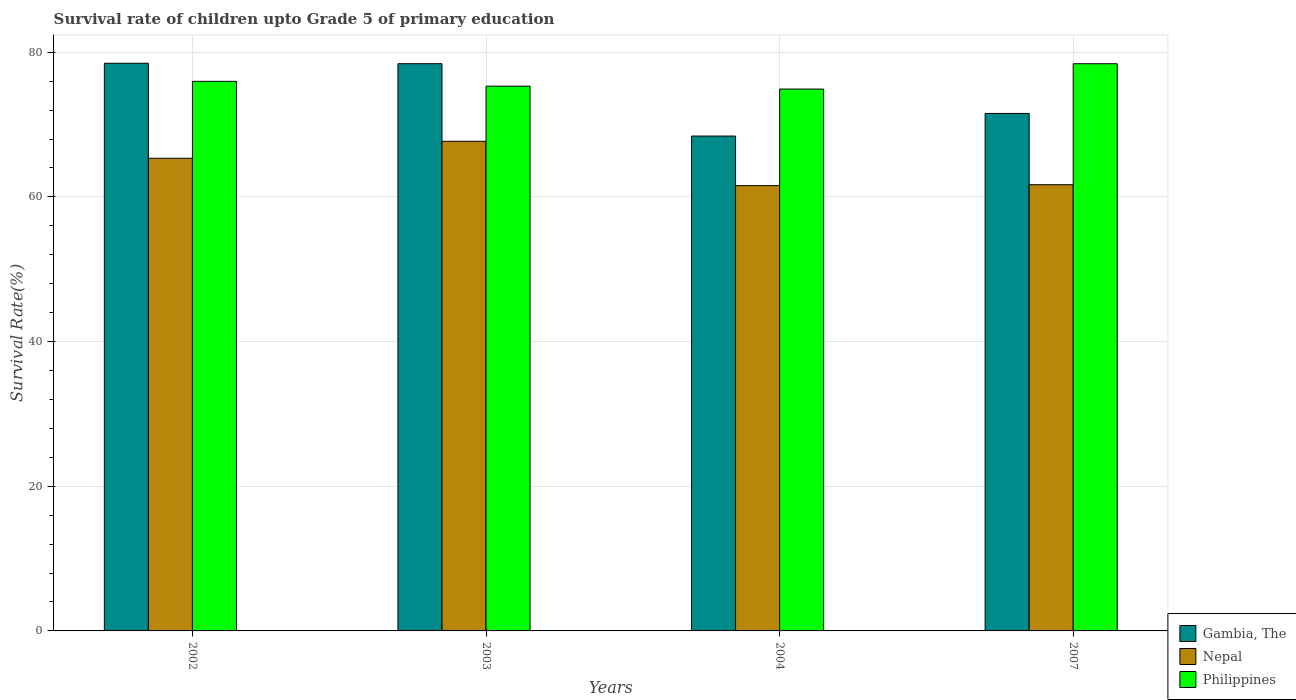How many different coloured bars are there?
Keep it short and to the point. 3. How many groups of bars are there?
Your answer should be compact. 4. Are the number of bars per tick equal to the number of legend labels?
Your answer should be compact. Yes. How many bars are there on the 1st tick from the left?
Give a very brief answer. 3. How many bars are there on the 2nd tick from the right?
Ensure brevity in your answer.  3. What is the label of the 4th group of bars from the left?
Keep it short and to the point. 2007. In how many cases, is the number of bars for a given year not equal to the number of legend labels?
Provide a short and direct response. 0. What is the survival rate of children in Gambia, The in 2004?
Offer a very short reply. 68.41. Across all years, what is the maximum survival rate of children in Philippines?
Make the answer very short. 78.41. Across all years, what is the minimum survival rate of children in Gambia, The?
Give a very brief answer. 68.41. In which year was the survival rate of children in Gambia, The maximum?
Your response must be concise. 2002. In which year was the survival rate of children in Nepal minimum?
Give a very brief answer. 2004. What is the total survival rate of children in Philippines in the graph?
Make the answer very short. 304.61. What is the difference between the survival rate of children in Philippines in 2002 and that in 2007?
Ensure brevity in your answer.  -2.43. What is the difference between the survival rate of children in Gambia, The in 2003 and the survival rate of children in Nepal in 2002?
Your answer should be very brief. 13.07. What is the average survival rate of children in Gambia, The per year?
Your response must be concise. 74.21. In the year 2004, what is the difference between the survival rate of children in Nepal and survival rate of children in Gambia, The?
Make the answer very short. -6.85. In how many years, is the survival rate of children in Gambia, The greater than 28 %?
Your answer should be compact. 4. What is the ratio of the survival rate of children in Gambia, The in 2002 to that in 2004?
Provide a succinct answer. 1.15. Is the survival rate of children in Gambia, The in 2002 less than that in 2007?
Your response must be concise. No. What is the difference between the highest and the second highest survival rate of children in Philippines?
Your answer should be compact. 2.43. What is the difference between the highest and the lowest survival rate of children in Nepal?
Your answer should be compact. 6.13. Is the sum of the survival rate of children in Gambia, The in 2002 and 2003 greater than the maximum survival rate of children in Philippines across all years?
Offer a terse response. Yes. What does the 2nd bar from the left in 2002 represents?
Provide a short and direct response. Nepal. What does the 2nd bar from the right in 2002 represents?
Provide a succinct answer. Nepal. Is it the case that in every year, the sum of the survival rate of children in Gambia, The and survival rate of children in Nepal is greater than the survival rate of children in Philippines?
Keep it short and to the point. Yes. How many bars are there?
Make the answer very short. 12. Are all the bars in the graph horizontal?
Give a very brief answer. No. Are the values on the major ticks of Y-axis written in scientific E-notation?
Your response must be concise. No. Does the graph contain grids?
Your response must be concise. Yes. Where does the legend appear in the graph?
Give a very brief answer. Bottom right. What is the title of the graph?
Offer a very short reply. Survival rate of children upto Grade 5 of primary education. What is the label or title of the X-axis?
Your response must be concise. Years. What is the label or title of the Y-axis?
Ensure brevity in your answer.  Survival Rate(%). What is the Survival Rate(%) in Gambia, The in 2002?
Make the answer very short. 78.48. What is the Survival Rate(%) of Nepal in 2002?
Your answer should be very brief. 65.34. What is the Survival Rate(%) of Philippines in 2002?
Your answer should be very brief. 75.98. What is the Survival Rate(%) in Gambia, The in 2003?
Provide a short and direct response. 78.41. What is the Survival Rate(%) in Nepal in 2003?
Provide a succinct answer. 67.69. What is the Survival Rate(%) in Philippines in 2003?
Provide a succinct answer. 75.31. What is the Survival Rate(%) of Gambia, The in 2004?
Provide a short and direct response. 68.41. What is the Survival Rate(%) of Nepal in 2004?
Offer a very short reply. 61.56. What is the Survival Rate(%) of Philippines in 2004?
Your answer should be compact. 74.91. What is the Survival Rate(%) in Gambia, The in 2007?
Keep it short and to the point. 71.54. What is the Survival Rate(%) of Nepal in 2007?
Offer a terse response. 61.69. What is the Survival Rate(%) in Philippines in 2007?
Give a very brief answer. 78.41. Across all years, what is the maximum Survival Rate(%) of Gambia, The?
Offer a very short reply. 78.48. Across all years, what is the maximum Survival Rate(%) in Nepal?
Make the answer very short. 67.69. Across all years, what is the maximum Survival Rate(%) of Philippines?
Offer a very short reply. 78.41. Across all years, what is the minimum Survival Rate(%) of Gambia, The?
Give a very brief answer. 68.41. Across all years, what is the minimum Survival Rate(%) of Nepal?
Ensure brevity in your answer.  61.56. Across all years, what is the minimum Survival Rate(%) in Philippines?
Ensure brevity in your answer.  74.91. What is the total Survival Rate(%) in Gambia, The in the graph?
Keep it short and to the point. 296.84. What is the total Survival Rate(%) of Nepal in the graph?
Give a very brief answer. 256.28. What is the total Survival Rate(%) of Philippines in the graph?
Offer a very short reply. 304.61. What is the difference between the Survival Rate(%) in Gambia, The in 2002 and that in 2003?
Give a very brief answer. 0.06. What is the difference between the Survival Rate(%) in Nepal in 2002 and that in 2003?
Make the answer very short. -2.35. What is the difference between the Survival Rate(%) of Philippines in 2002 and that in 2003?
Offer a terse response. 0.67. What is the difference between the Survival Rate(%) of Gambia, The in 2002 and that in 2004?
Provide a succinct answer. 10.06. What is the difference between the Survival Rate(%) of Nepal in 2002 and that in 2004?
Keep it short and to the point. 3.78. What is the difference between the Survival Rate(%) of Philippines in 2002 and that in 2004?
Offer a very short reply. 1.07. What is the difference between the Survival Rate(%) of Gambia, The in 2002 and that in 2007?
Offer a very short reply. 6.94. What is the difference between the Survival Rate(%) in Nepal in 2002 and that in 2007?
Your answer should be very brief. 3.66. What is the difference between the Survival Rate(%) of Philippines in 2002 and that in 2007?
Your answer should be very brief. -2.43. What is the difference between the Survival Rate(%) of Gambia, The in 2003 and that in 2004?
Give a very brief answer. 10. What is the difference between the Survival Rate(%) of Nepal in 2003 and that in 2004?
Give a very brief answer. 6.13. What is the difference between the Survival Rate(%) of Philippines in 2003 and that in 2004?
Your response must be concise. 0.4. What is the difference between the Survival Rate(%) in Gambia, The in 2003 and that in 2007?
Give a very brief answer. 6.87. What is the difference between the Survival Rate(%) of Nepal in 2003 and that in 2007?
Offer a terse response. 6. What is the difference between the Survival Rate(%) in Philippines in 2003 and that in 2007?
Offer a very short reply. -3.1. What is the difference between the Survival Rate(%) in Gambia, The in 2004 and that in 2007?
Make the answer very short. -3.13. What is the difference between the Survival Rate(%) in Nepal in 2004 and that in 2007?
Provide a succinct answer. -0.13. What is the difference between the Survival Rate(%) in Philippines in 2004 and that in 2007?
Your answer should be very brief. -3.5. What is the difference between the Survival Rate(%) in Gambia, The in 2002 and the Survival Rate(%) in Nepal in 2003?
Keep it short and to the point. 10.79. What is the difference between the Survival Rate(%) in Gambia, The in 2002 and the Survival Rate(%) in Philippines in 2003?
Your response must be concise. 3.17. What is the difference between the Survival Rate(%) in Nepal in 2002 and the Survival Rate(%) in Philippines in 2003?
Offer a terse response. -9.97. What is the difference between the Survival Rate(%) in Gambia, The in 2002 and the Survival Rate(%) in Nepal in 2004?
Your answer should be very brief. 16.92. What is the difference between the Survival Rate(%) of Gambia, The in 2002 and the Survival Rate(%) of Philippines in 2004?
Give a very brief answer. 3.57. What is the difference between the Survival Rate(%) of Nepal in 2002 and the Survival Rate(%) of Philippines in 2004?
Your answer should be compact. -9.57. What is the difference between the Survival Rate(%) in Gambia, The in 2002 and the Survival Rate(%) in Nepal in 2007?
Ensure brevity in your answer.  16.79. What is the difference between the Survival Rate(%) of Gambia, The in 2002 and the Survival Rate(%) of Philippines in 2007?
Your answer should be very brief. 0.07. What is the difference between the Survival Rate(%) in Nepal in 2002 and the Survival Rate(%) in Philippines in 2007?
Offer a very short reply. -13.07. What is the difference between the Survival Rate(%) in Gambia, The in 2003 and the Survival Rate(%) in Nepal in 2004?
Your answer should be very brief. 16.86. What is the difference between the Survival Rate(%) in Gambia, The in 2003 and the Survival Rate(%) in Philippines in 2004?
Offer a terse response. 3.5. What is the difference between the Survival Rate(%) of Nepal in 2003 and the Survival Rate(%) of Philippines in 2004?
Provide a succinct answer. -7.22. What is the difference between the Survival Rate(%) of Gambia, The in 2003 and the Survival Rate(%) of Nepal in 2007?
Keep it short and to the point. 16.73. What is the difference between the Survival Rate(%) of Gambia, The in 2003 and the Survival Rate(%) of Philippines in 2007?
Ensure brevity in your answer.  0. What is the difference between the Survival Rate(%) in Nepal in 2003 and the Survival Rate(%) in Philippines in 2007?
Offer a very short reply. -10.72. What is the difference between the Survival Rate(%) of Gambia, The in 2004 and the Survival Rate(%) of Nepal in 2007?
Your answer should be compact. 6.73. What is the difference between the Survival Rate(%) in Gambia, The in 2004 and the Survival Rate(%) in Philippines in 2007?
Keep it short and to the point. -10. What is the difference between the Survival Rate(%) in Nepal in 2004 and the Survival Rate(%) in Philippines in 2007?
Make the answer very short. -16.85. What is the average Survival Rate(%) of Gambia, The per year?
Your answer should be compact. 74.21. What is the average Survival Rate(%) in Nepal per year?
Offer a very short reply. 64.07. What is the average Survival Rate(%) of Philippines per year?
Make the answer very short. 76.15. In the year 2002, what is the difference between the Survival Rate(%) of Gambia, The and Survival Rate(%) of Nepal?
Give a very brief answer. 13.13. In the year 2002, what is the difference between the Survival Rate(%) in Gambia, The and Survival Rate(%) in Philippines?
Your response must be concise. 2.5. In the year 2002, what is the difference between the Survival Rate(%) of Nepal and Survival Rate(%) of Philippines?
Keep it short and to the point. -10.63. In the year 2003, what is the difference between the Survival Rate(%) in Gambia, The and Survival Rate(%) in Nepal?
Provide a succinct answer. 10.73. In the year 2003, what is the difference between the Survival Rate(%) of Gambia, The and Survival Rate(%) of Philippines?
Make the answer very short. 3.11. In the year 2003, what is the difference between the Survival Rate(%) of Nepal and Survival Rate(%) of Philippines?
Ensure brevity in your answer.  -7.62. In the year 2004, what is the difference between the Survival Rate(%) in Gambia, The and Survival Rate(%) in Nepal?
Your answer should be very brief. 6.85. In the year 2004, what is the difference between the Survival Rate(%) in Gambia, The and Survival Rate(%) in Philippines?
Offer a very short reply. -6.5. In the year 2004, what is the difference between the Survival Rate(%) of Nepal and Survival Rate(%) of Philippines?
Your response must be concise. -13.35. In the year 2007, what is the difference between the Survival Rate(%) in Gambia, The and Survival Rate(%) in Nepal?
Your answer should be very brief. 9.85. In the year 2007, what is the difference between the Survival Rate(%) of Gambia, The and Survival Rate(%) of Philippines?
Ensure brevity in your answer.  -6.87. In the year 2007, what is the difference between the Survival Rate(%) of Nepal and Survival Rate(%) of Philippines?
Provide a short and direct response. -16.72. What is the ratio of the Survival Rate(%) of Gambia, The in 2002 to that in 2003?
Your answer should be very brief. 1. What is the ratio of the Survival Rate(%) in Nepal in 2002 to that in 2003?
Offer a very short reply. 0.97. What is the ratio of the Survival Rate(%) in Philippines in 2002 to that in 2003?
Your response must be concise. 1.01. What is the ratio of the Survival Rate(%) of Gambia, The in 2002 to that in 2004?
Provide a succinct answer. 1.15. What is the ratio of the Survival Rate(%) in Nepal in 2002 to that in 2004?
Ensure brevity in your answer.  1.06. What is the ratio of the Survival Rate(%) in Philippines in 2002 to that in 2004?
Offer a very short reply. 1.01. What is the ratio of the Survival Rate(%) of Gambia, The in 2002 to that in 2007?
Your answer should be very brief. 1.1. What is the ratio of the Survival Rate(%) in Nepal in 2002 to that in 2007?
Offer a terse response. 1.06. What is the ratio of the Survival Rate(%) in Gambia, The in 2003 to that in 2004?
Keep it short and to the point. 1.15. What is the ratio of the Survival Rate(%) in Nepal in 2003 to that in 2004?
Give a very brief answer. 1.1. What is the ratio of the Survival Rate(%) in Philippines in 2003 to that in 2004?
Your answer should be very brief. 1.01. What is the ratio of the Survival Rate(%) of Gambia, The in 2003 to that in 2007?
Your answer should be very brief. 1.1. What is the ratio of the Survival Rate(%) in Nepal in 2003 to that in 2007?
Keep it short and to the point. 1.1. What is the ratio of the Survival Rate(%) in Philippines in 2003 to that in 2007?
Keep it short and to the point. 0.96. What is the ratio of the Survival Rate(%) in Gambia, The in 2004 to that in 2007?
Give a very brief answer. 0.96. What is the ratio of the Survival Rate(%) of Nepal in 2004 to that in 2007?
Keep it short and to the point. 1. What is the ratio of the Survival Rate(%) in Philippines in 2004 to that in 2007?
Your response must be concise. 0.96. What is the difference between the highest and the second highest Survival Rate(%) of Gambia, The?
Your response must be concise. 0.06. What is the difference between the highest and the second highest Survival Rate(%) in Nepal?
Your response must be concise. 2.35. What is the difference between the highest and the second highest Survival Rate(%) of Philippines?
Keep it short and to the point. 2.43. What is the difference between the highest and the lowest Survival Rate(%) in Gambia, The?
Make the answer very short. 10.06. What is the difference between the highest and the lowest Survival Rate(%) in Nepal?
Give a very brief answer. 6.13. What is the difference between the highest and the lowest Survival Rate(%) in Philippines?
Provide a succinct answer. 3.5. 